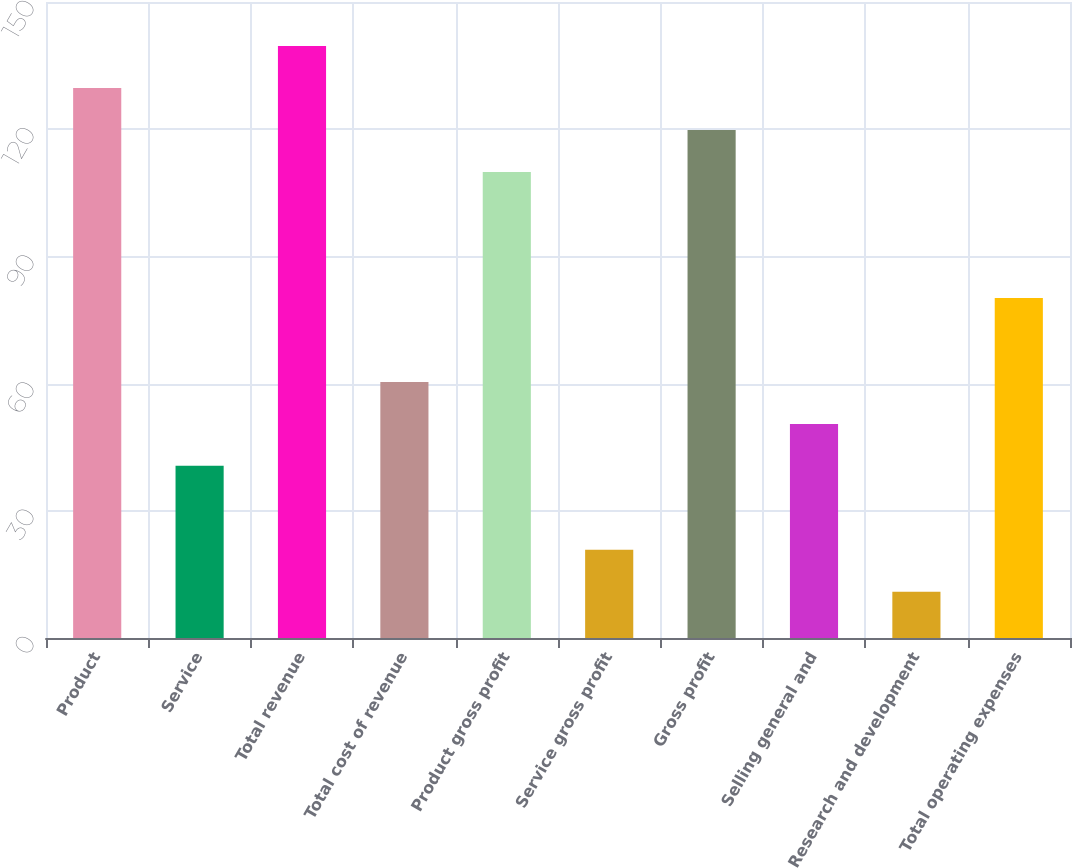<chart> <loc_0><loc_0><loc_500><loc_500><bar_chart><fcel>Product<fcel>Service<fcel>Total revenue<fcel>Total cost of revenue<fcel>Product gross profit<fcel>Service gross profit<fcel>Gross profit<fcel>Selling general and<fcel>Research and development<fcel>Total operating expenses<nl><fcel>129.7<fcel>40.6<fcel>139.6<fcel>60.4<fcel>109.9<fcel>20.8<fcel>119.8<fcel>50.5<fcel>10.9<fcel>80.2<nl></chart> 